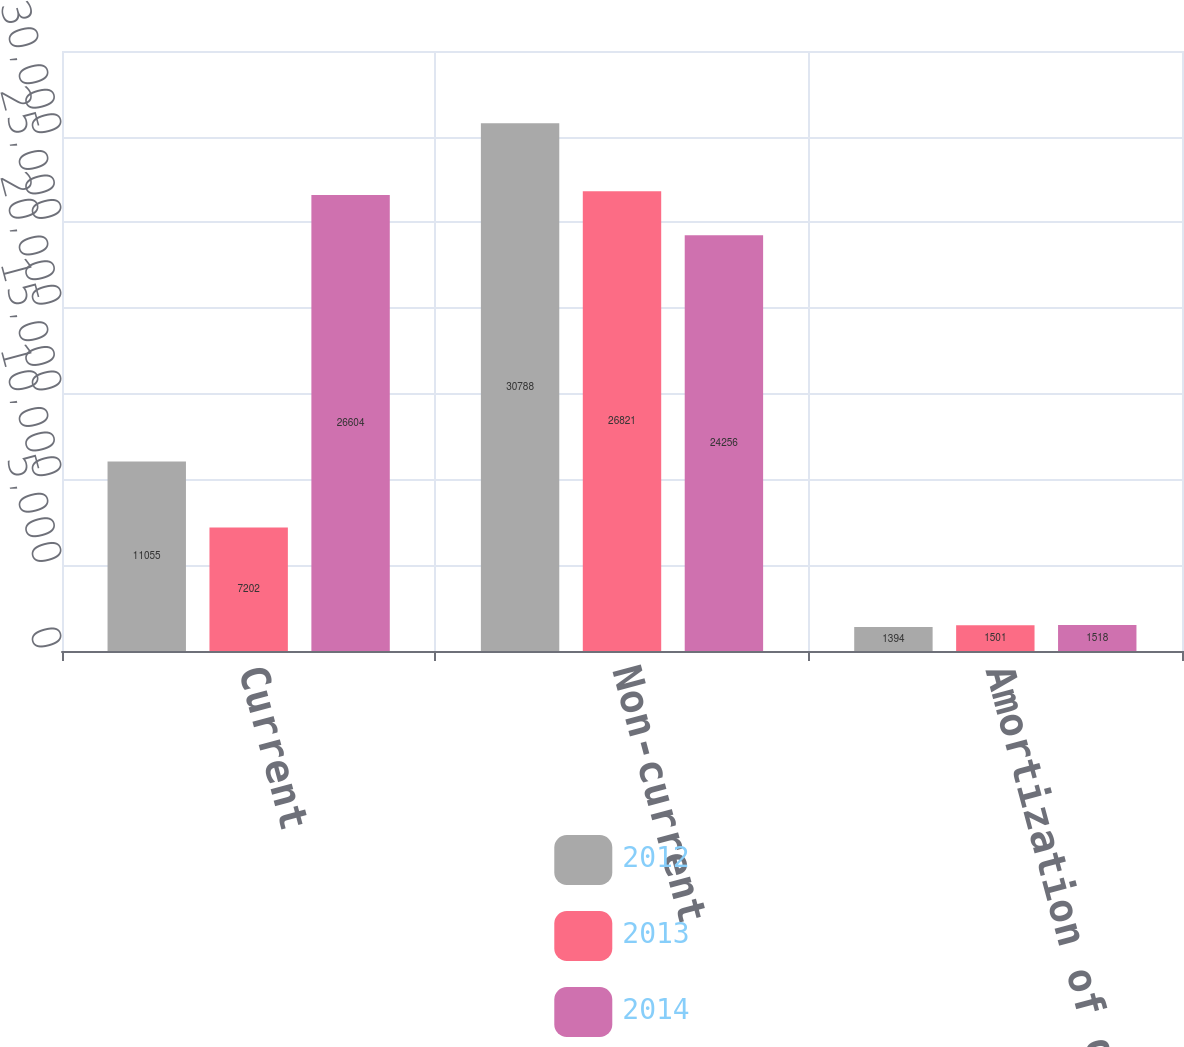Convert chart to OTSL. <chart><loc_0><loc_0><loc_500><loc_500><stacked_bar_chart><ecel><fcel>Current<fcel>Non-current<fcel>Amortization of deferred<nl><fcel>2012<fcel>11055<fcel>30788<fcel>1394<nl><fcel>2013<fcel>7202<fcel>26821<fcel>1501<nl><fcel>2014<fcel>26604<fcel>24256<fcel>1518<nl></chart> 